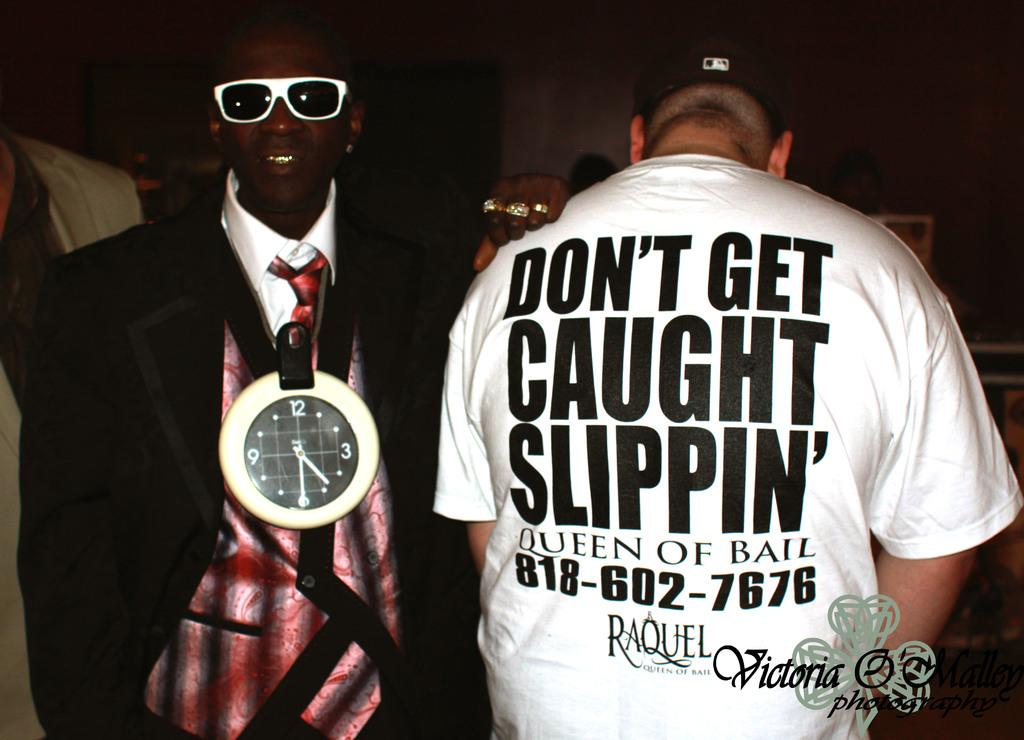<image>
Share a concise interpretation of the image provided. A man wearing a clock on his neck stands next to a man wearing a shirt that reads"Queen of Bail" on the back. 